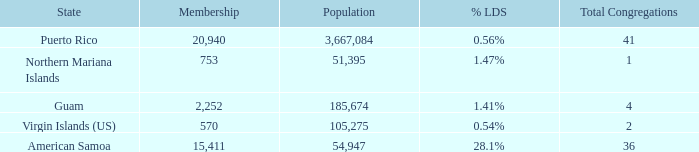What is the total number of Total Congregations, when % LDS is 0.54%, and when Population is greater than 105,275? 0.0. 